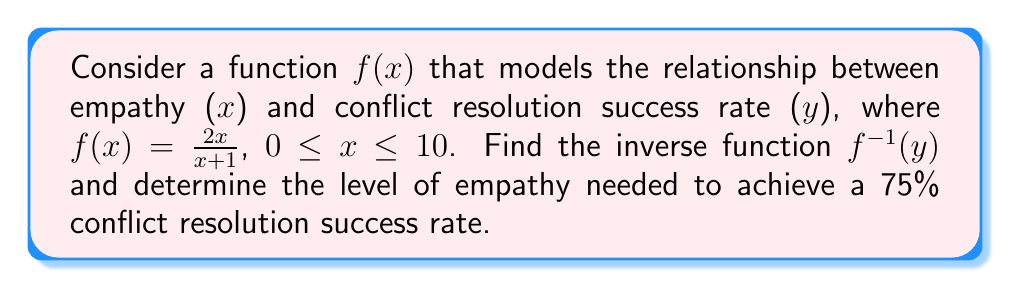Give your solution to this math problem. 1) To find the inverse function, we first replace $f(x)$ with $y$:
   $y = \frac{2x}{x+1}$

2) Swap $x$ and $y$:
   $x = \frac{2y}{y+1}$

3) Solve for $y$:
   $x(y+1) = 2y$
   $xy + x = 2y$
   $xy - 2y = -x$
   $y(x-2) = -x$
   $y = \frac{-x}{x-2}$

4) Therefore, the inverse function is:
   $f^{-1}(y) = \frac{-y}{y-2}$

5) To find the level of empathy needed for a 75% success rate, we substitute $y = 0.75$ into $f^{-1}(y)$:
   $f^{-1}(0.75) = \frac{-0.75}{0.75-2} = \frac{-0.75}{-1.25} = 0.6$

6) Interpret the result: An empathy level of 0.6 (on a scale from 0 to 10) is needed to achieve a 75% conflict resolution success rate.
Answer: $f^{-1}(y) = \frac{-y}{y-2}$; Empathy level: 0.6 